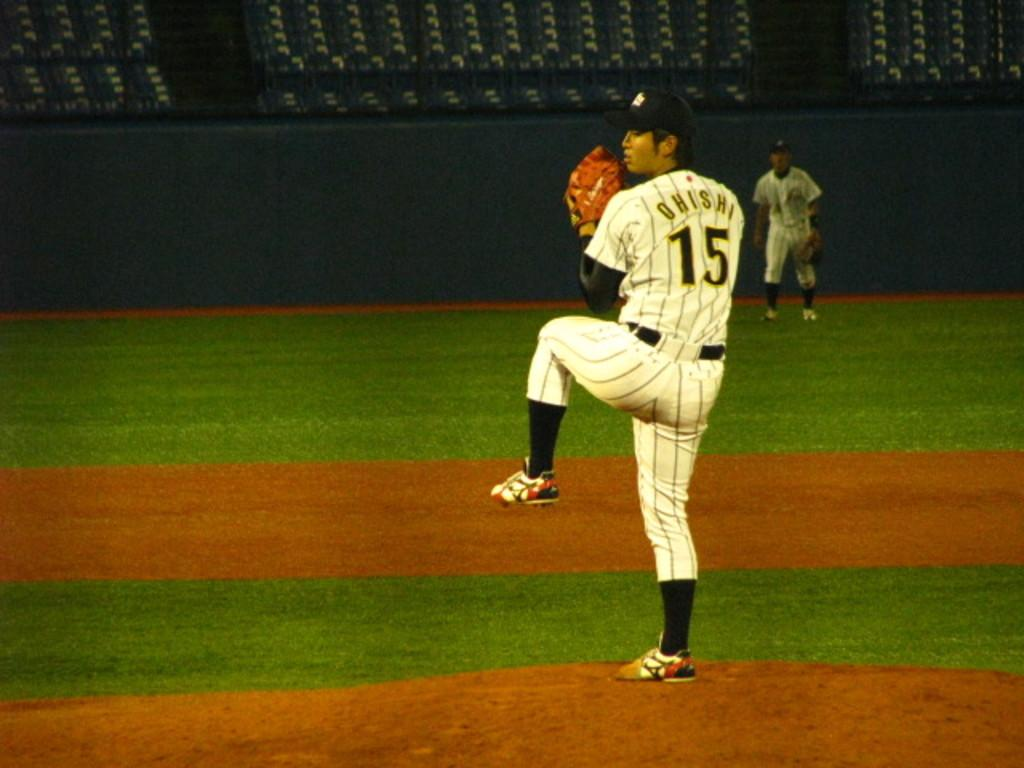<image>
Create a compact narrative representing the image presented. a baseball player that is wearing the number 15 